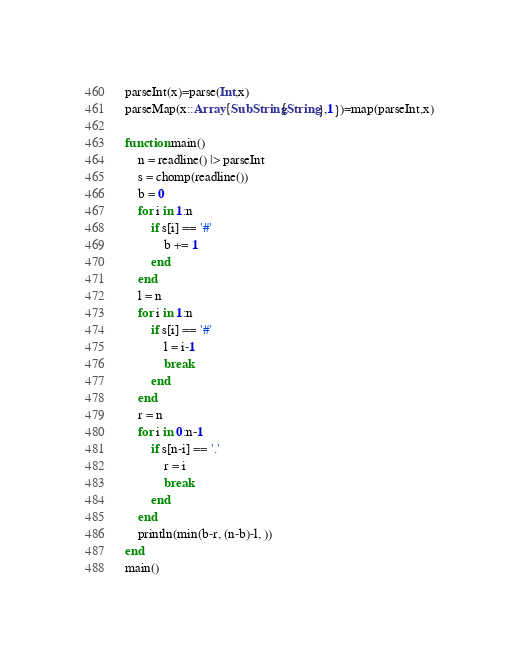<code> <loc_0><loc_0><loc_500><loc_500><_Julia_>parseInt(x)=parse(Int,x)
parseMap(x::Array{SubString{String},1})=map(parseInt,x)

function main()
	n = readline() |> parseInt
	s = chomp(readline())
	b = 0
	for i in 1:n
		if s[i] == '#'
			b += 1
		end
	end
	l = n
	for i in 1:n
		if s[i] == '#'
			l = i-1
			break
		end
	end
	r = n
	for i in 0:n-1
		if s[n-i] == '.'
			r = i
			break
		end
	end
	println(min(b-r, (n-b)-l, ))
end
main()
</code> 